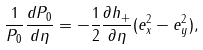Convert formula to latex. <formula><loc_0><loc_0><loc_500><loc_500>\frac { 1 } { P _ { 0 } } \frac { d P _ { 0 } } { d \eta } = - \frac { 1 } { 2 } \frac { \partial h _ { + } } { \partial \eta } ( e ^ { 2 } _ { x } - e ^ { 2 } _ { y } ) ,</formula> 